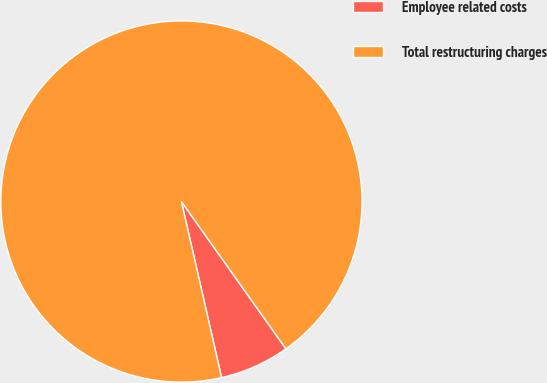Convert chart. <chart><loc_0><loc_0><loc_500><loc_500><pie_chart><fcel>Employee related costs<fcel>Total restructuring charges<nl><fcel>6.25%<fcel>93.75%<nl></chart> 